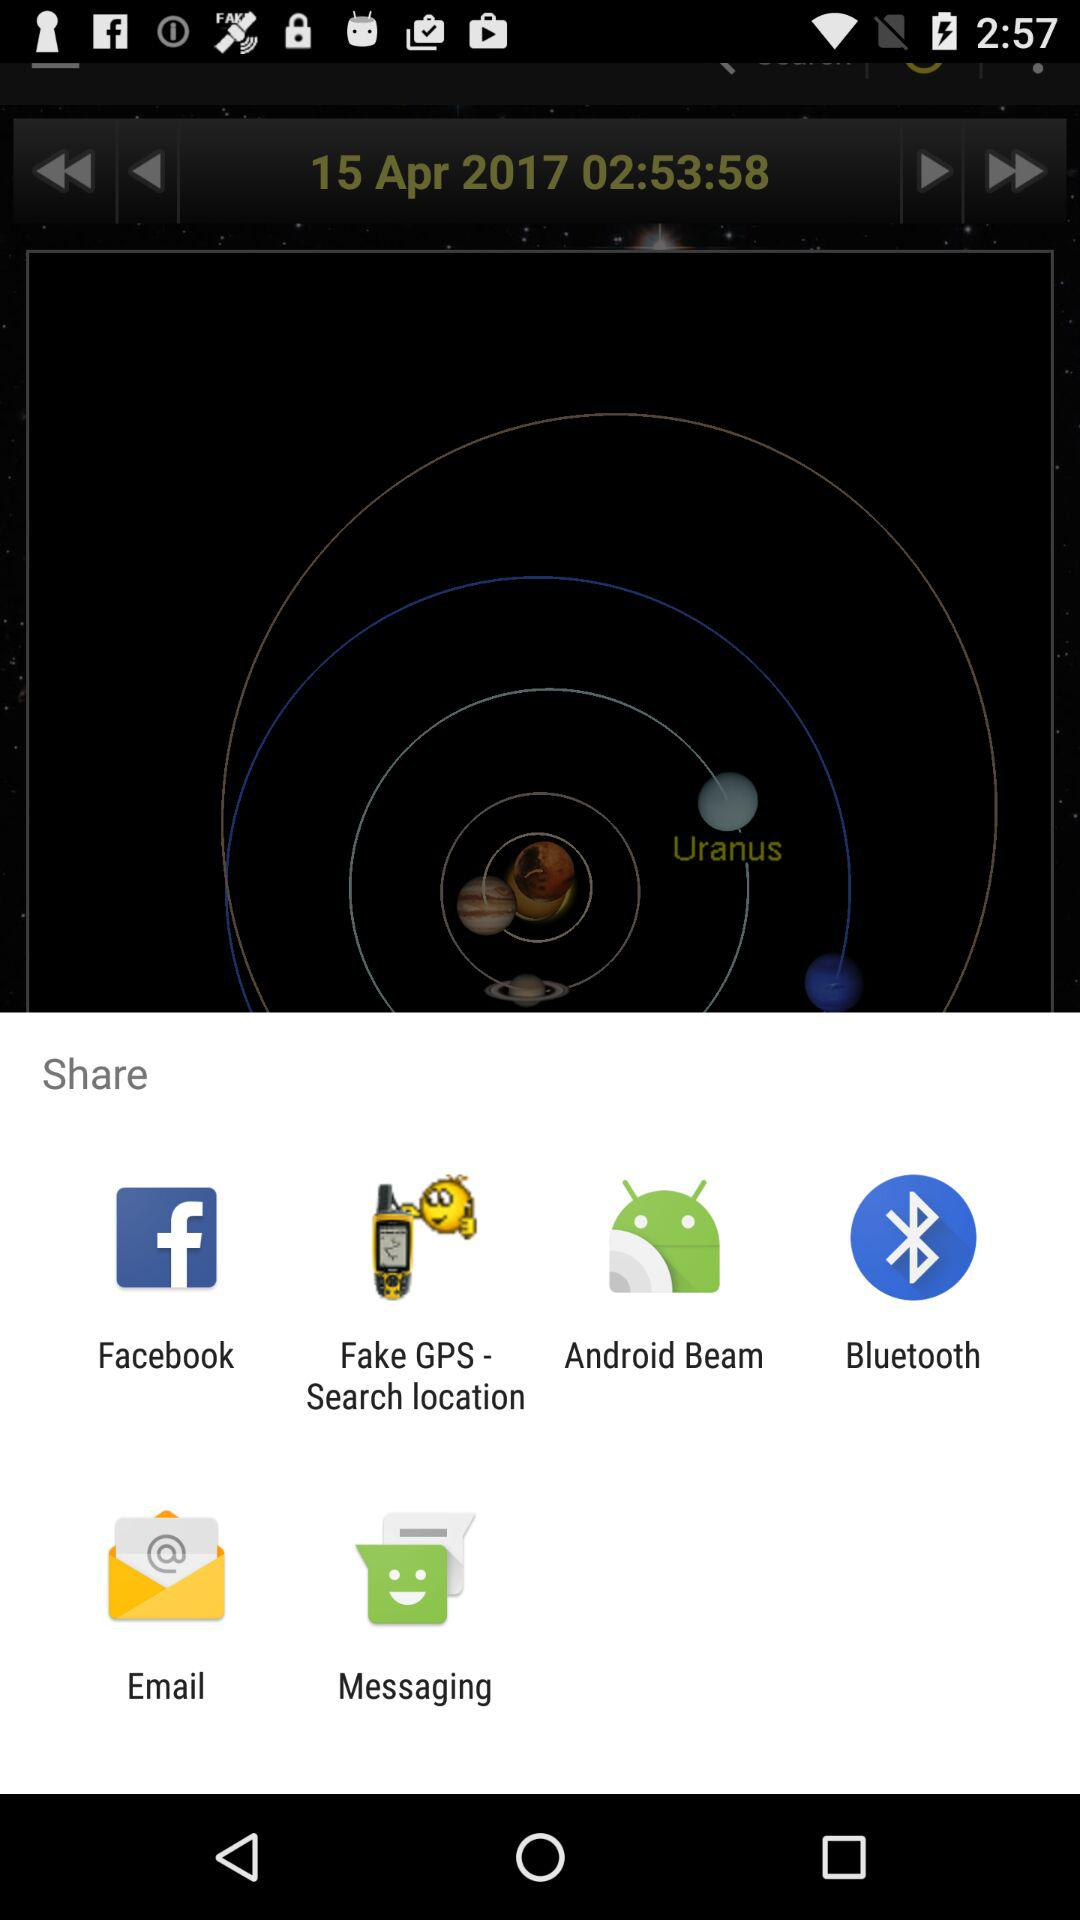Through which applications can we share? You can share through "Facebook", "Fake GPS - Search location", "Android Beam", "Bluetooth", "Email" and "Messaging". 